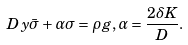<formula> <loc_0><loc_0><loc_500><loc_500>\ D y \bar { \sigma } + \alpha \sigma = \rho g , \alpha = \frac { 2 \delta K } { D } .</formula> 